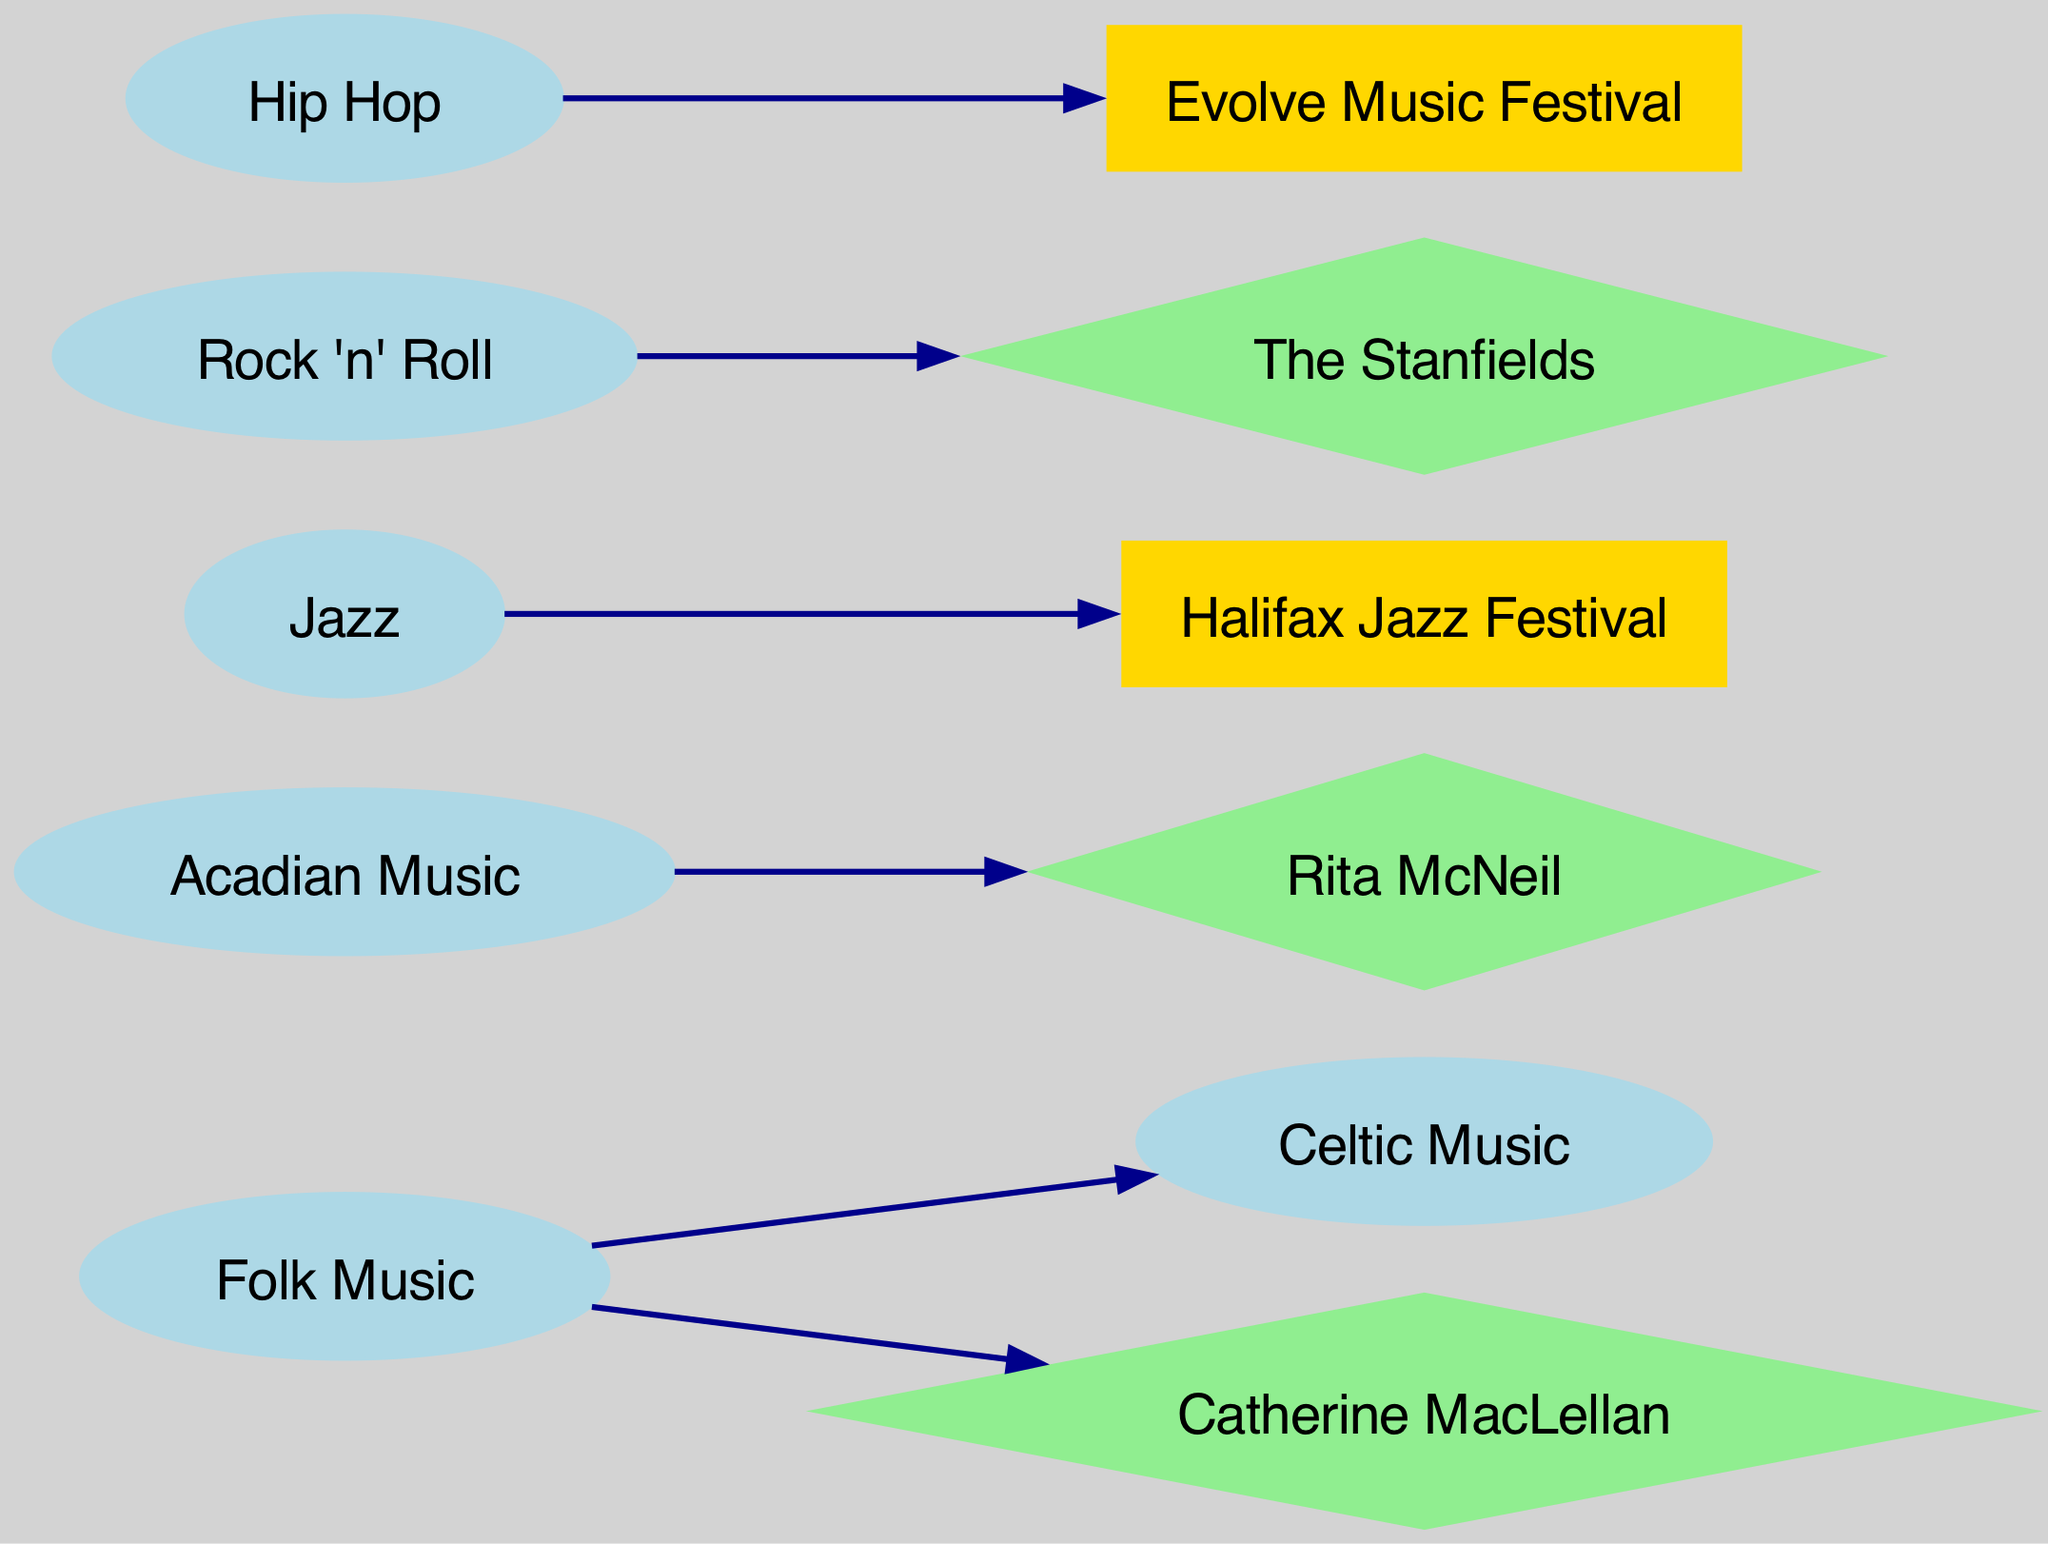What is the total number of nodes in the diagram? The diagram contains nodes representing different musical styles and influential figures. By counting the nodes listed, we see there are 10 nodes in total.
Answer: 10 Which musical style is connected to Catherine MacLellan? The diagram shows a directed edge from Folk Music to Catherine MacLellan. Therefore, Folk Music is the musical style connected to her.
Answer: Folk Music How many edges are present in the diagram? Edges in the diagram show the relationships between the musical styles and influential figures. By counting the edges listed, we find there are 6 edges.
Answer: 6 Which festival is linked to Jazz? The diagram features a directed edge from Jazz to Halifax Jazz Festival. Thus, the festival linked to Jazz is the Halifax Jazz Festival.
Answer: Halifax Jazz Festival What genre is connected to Evolve Music Festival? The diagram indicates a directed edge from Hip Hop to Evolve Music Festival, meaning Hip Hop is the genre connected to the festival.
Answer: Hip Hop Which two musical styles are linked together in the diagram? From the edges, we can see there's a connection from Folk Music to Celtic Music, indicating they are linked.
Answer: Folk Music and Celtic Music Name an influential figure related to Acadian Music. The diagram shows a directed edge from Acadian Music to Rita McNeil, making her the influential figure related to Acadian Music.
Answer: Rita McNeil What shape represents festivals in the diagram? The diagram distinguishes nodes of festivals with a rectangle shape, specifically used for nodes like Halifax Jazz Festival and Evolve Music Festival.
Answer: Rectangle Which musical style influences The Stanfields? The directed edge from Rock 'n' Roll to The Stanfields indicates that Rock 'n' Roll influences this group.
Answer: Rock 'n' Roll 